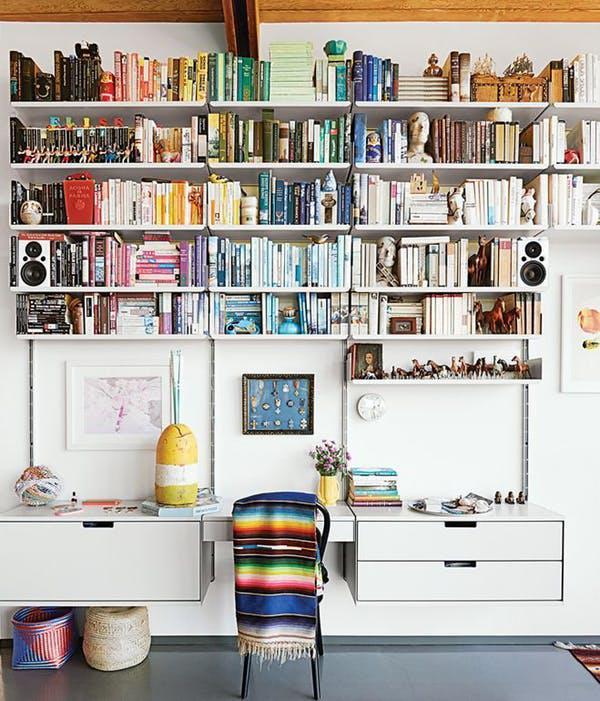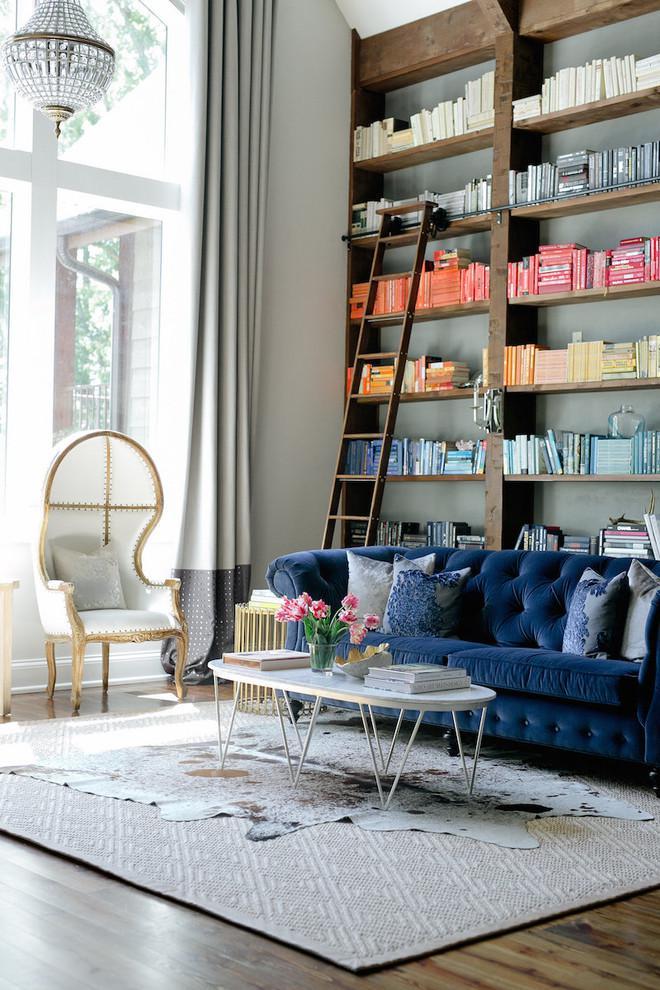The first image is the image on the left, the second image is the image on the right. Given the left and right images, does the statement "A bookshelf sits behind a couch in a yellow room in one of the images." hold true? Answer yes or no. No. The first image is the image on the left, the second image is the image on the right. Considering the images on both sides, is "A tufted royal blue sofa is in front of a wall-filling bookcase that is not white." valid? Answer yes or no. Yes. 